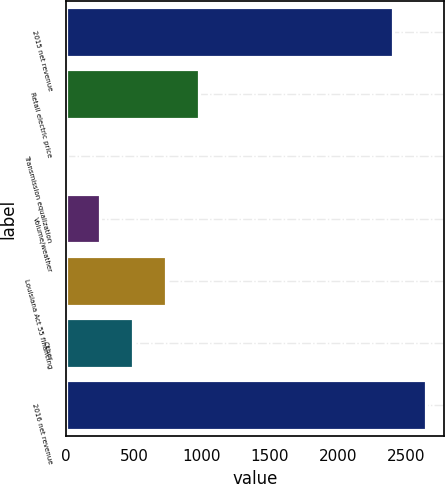Convert chart to OTSL. <chart><loc_0><loc_0><loc_500><loc_500><bar_chart><fcel>2015 net revenue<fcel>Retail electric price<fcel>Transmission equalization<fcel>Volume/weather<fcel>Louisiana Act 55 financing<fcel>Other<fcel>2016 net revenue<nl><fcel>2408.8<fcel>979.26<fcel>6.5<fcel>249.69<fcel>736.07<fcel>492.88<fcel>2651.99<nl></chart> 